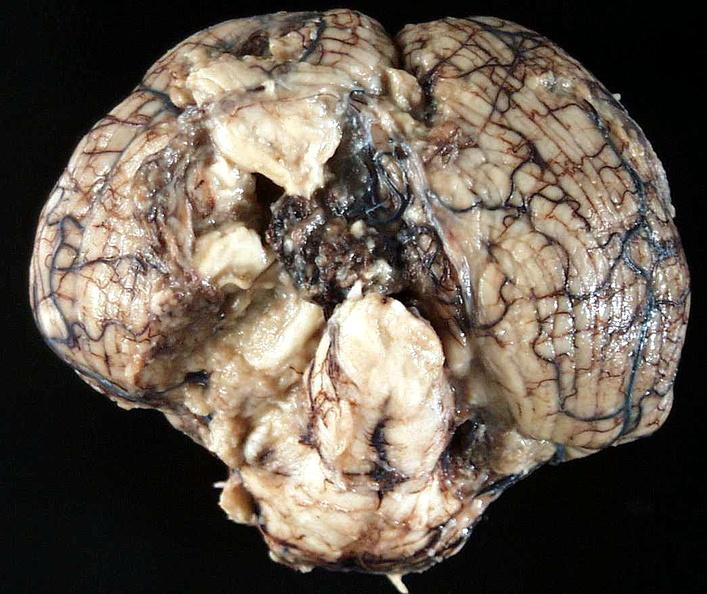s nervous present?
Answer the question using a single word or phrase. Yes 